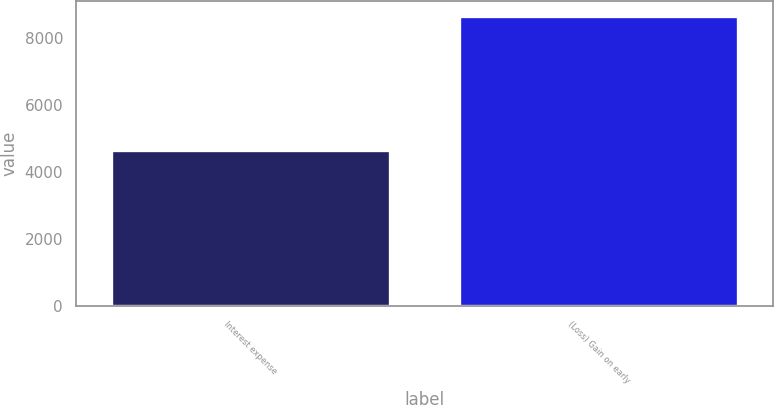Convert chart. <chart><loc_0><loc_0><loc_500><loc_500><bar_chart><fcel>Interest expense<fcel>(Loss) Gain on early<nl><fcel>4646<fcel>8656<nl></chart> 